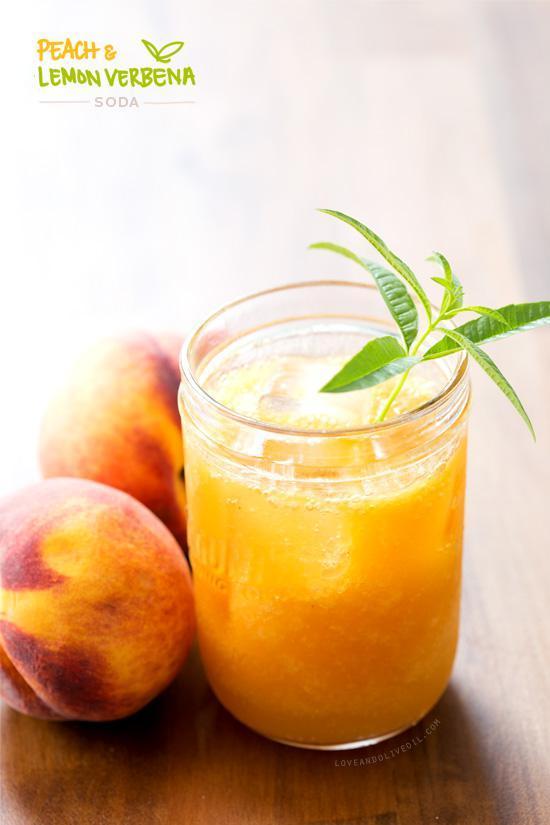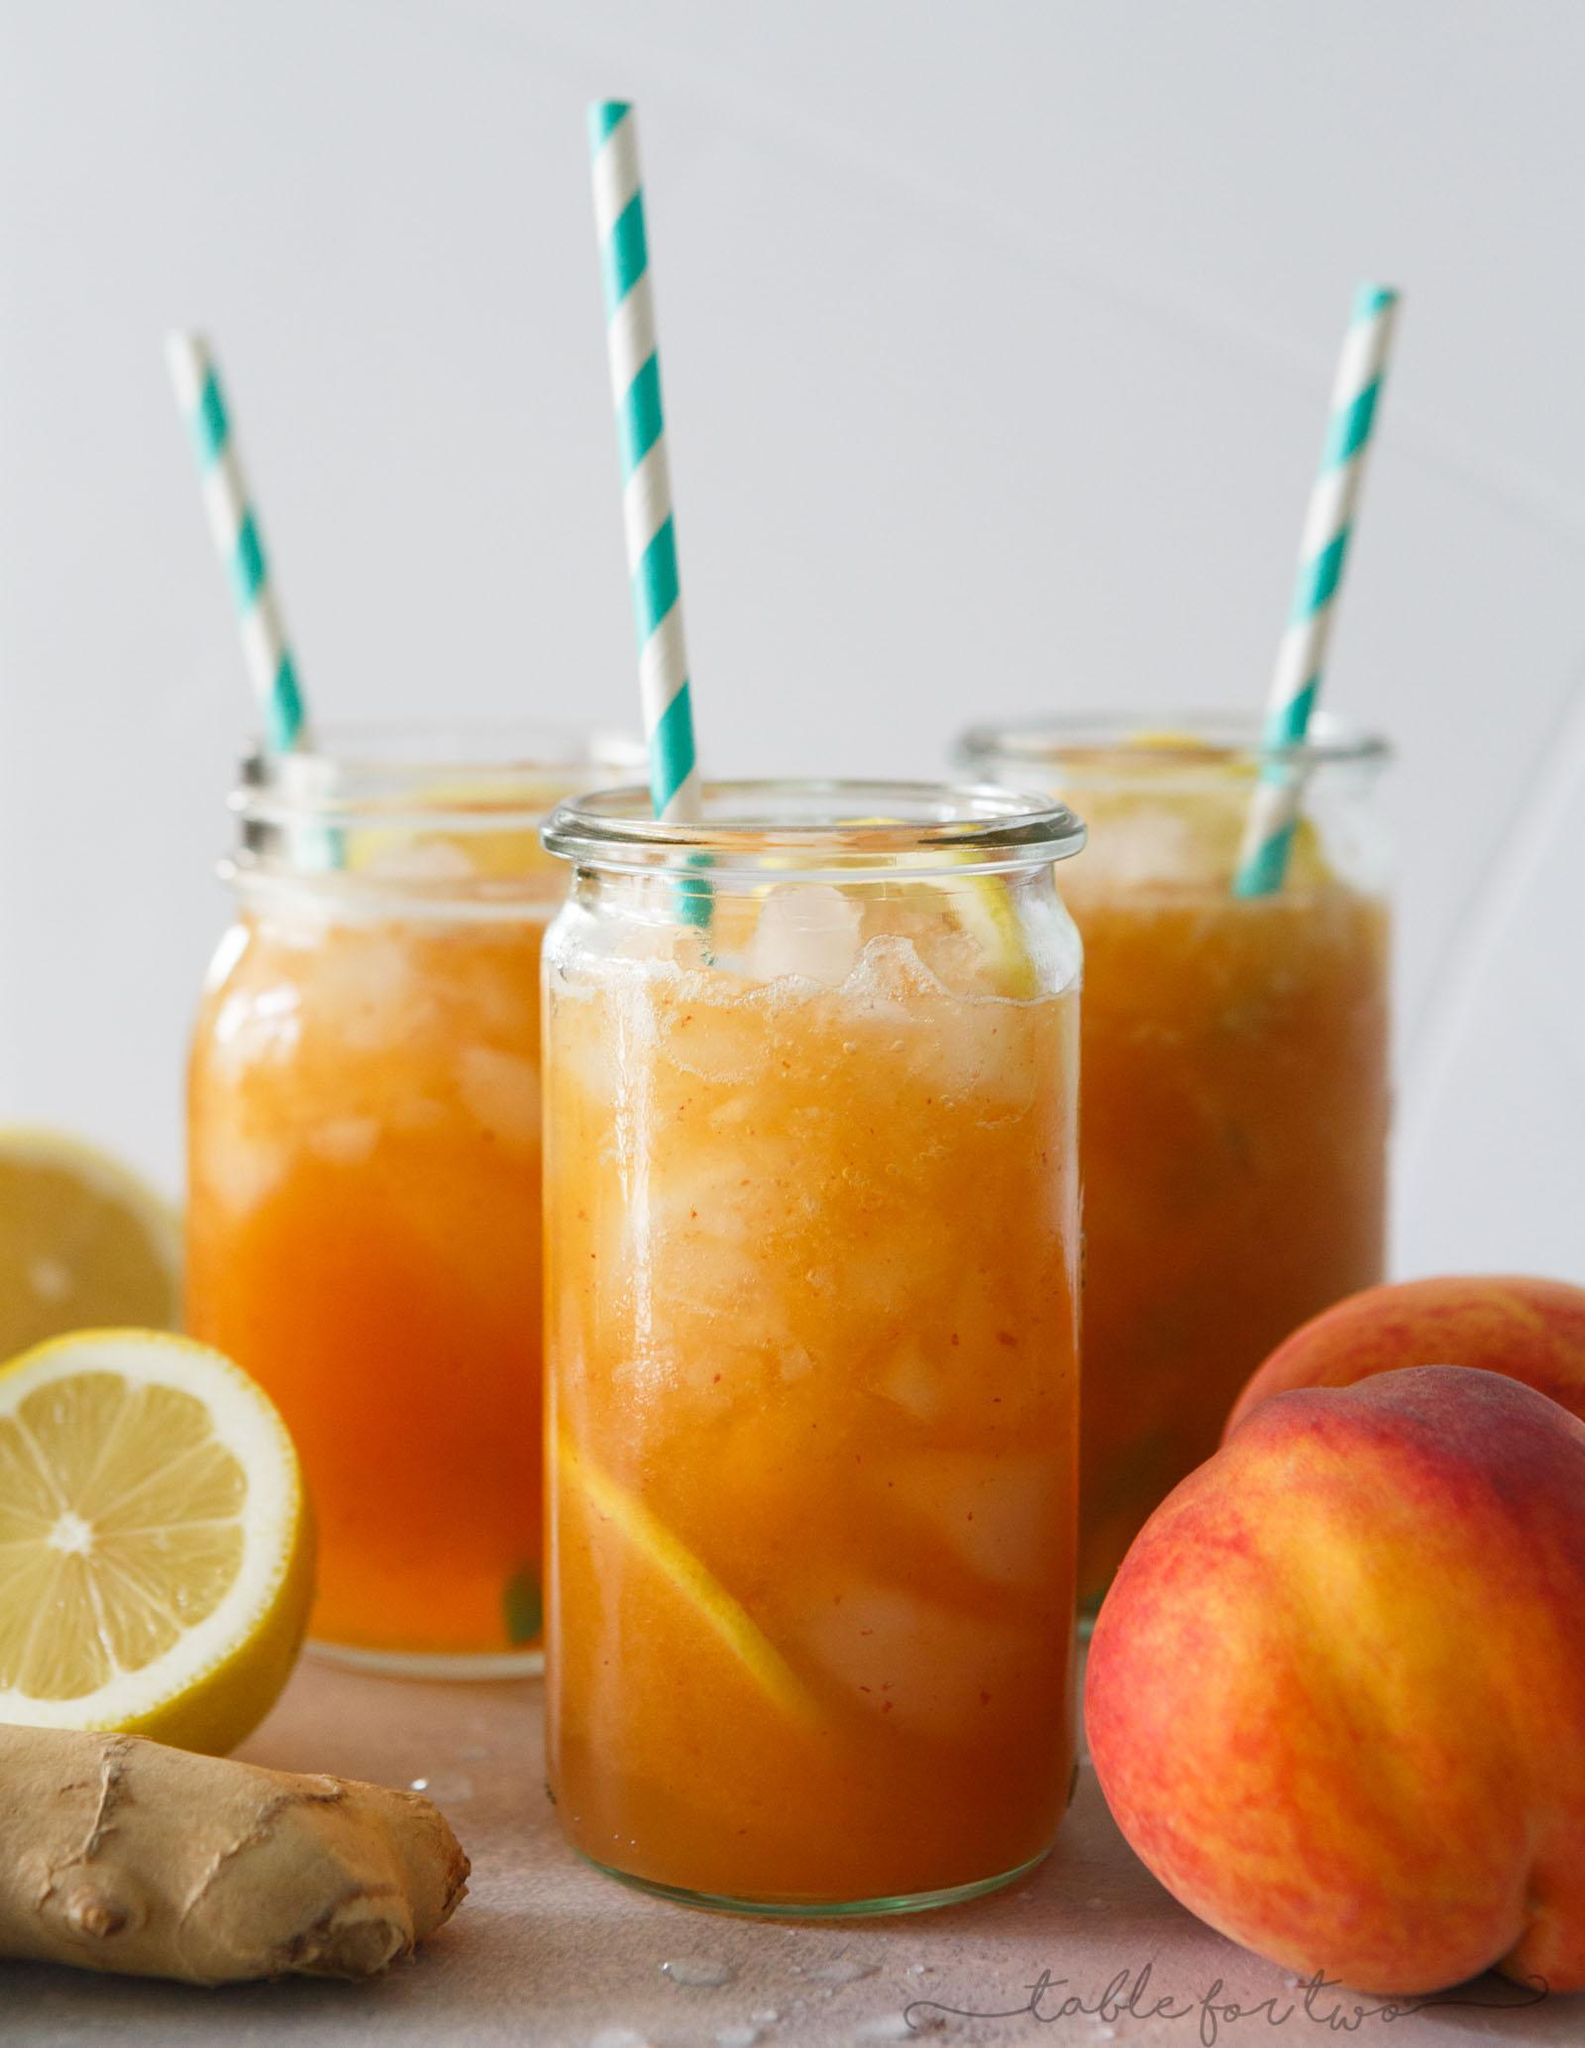The first image is the image on the left, the second image is the image on the right. Examine the images to the left and right. Is the description "The right image contains two sliced lemons hanging from the lid of two glass smoothie cups." accurate? Answer yes or no. No. 